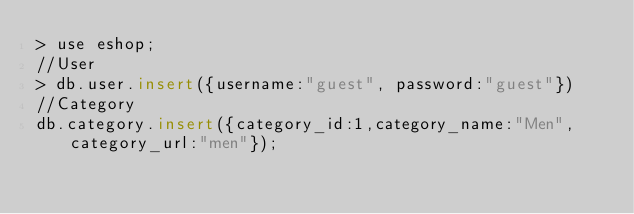Convert code to text. <code><loc_0><loc_0><loc_500><loc_500><_SQL_>> use eshop;
//User
> db.user.insert({username:"guest", password:"guest"})
//Category
db.category.insert({category_id:1,category_name:"Men", category_url:"men"});</code> 